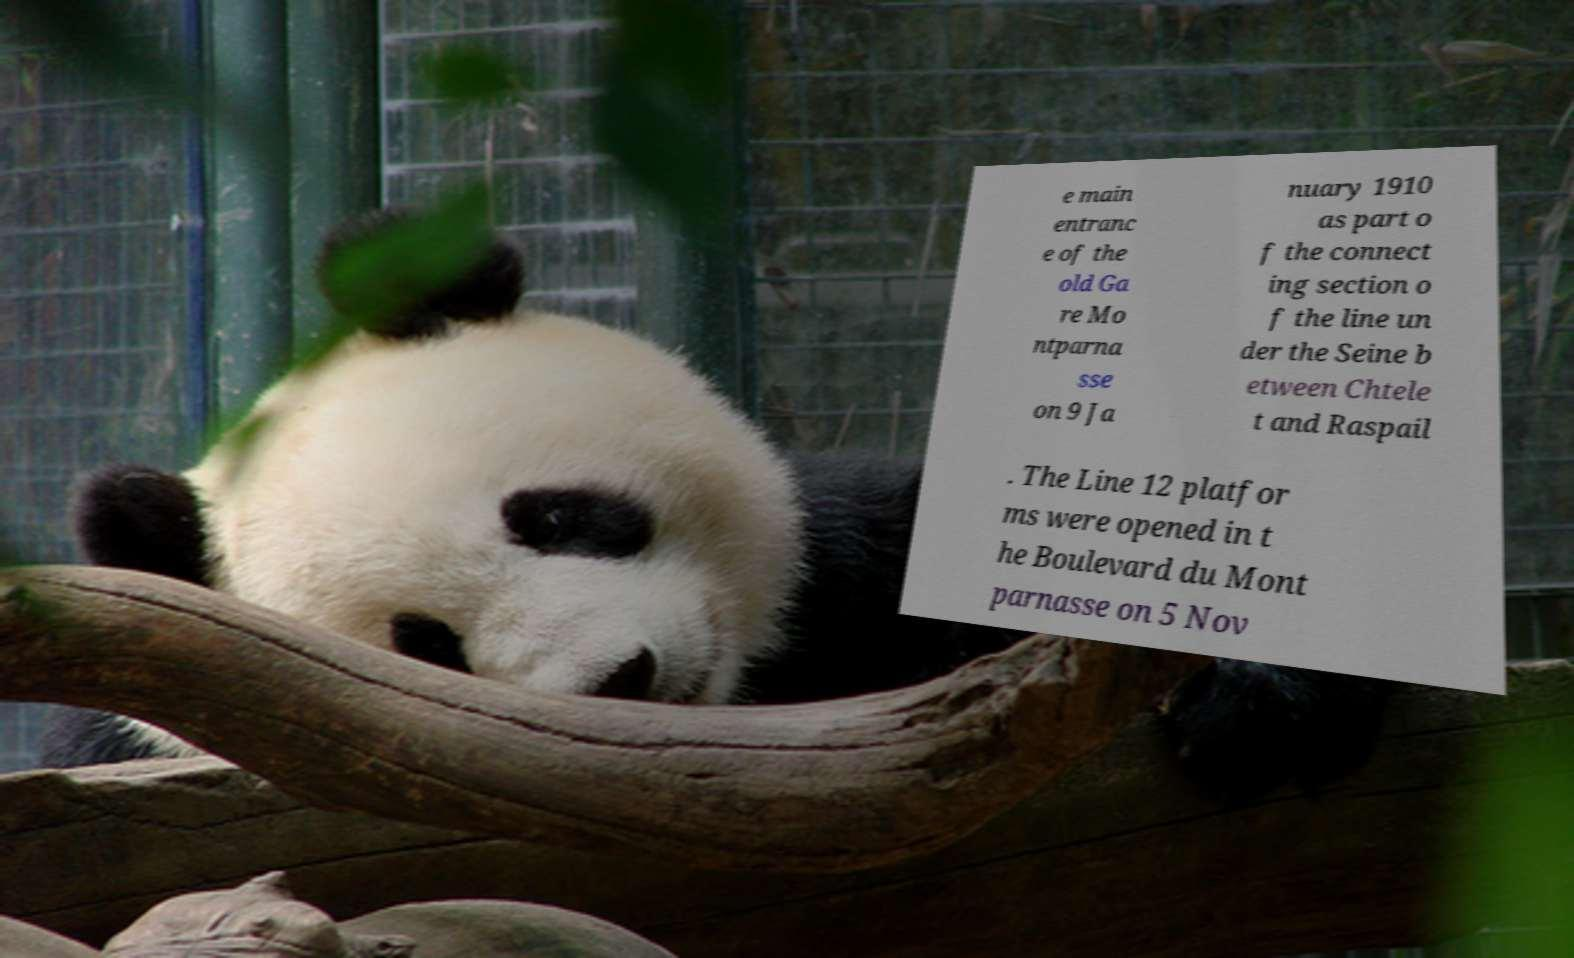Could you assist in decoding the text presented in this image and type it out clearly? e main entranc e of the old Ga re Mo ntparna sse on 9 Ja nuary 1910 as part o f the connect ing section o f the line un der the Seine b etween Chtele t and Raspail . The Line 12 platfor ms were opened in t he Boulevard du Mont parnasse on 5 Nov 